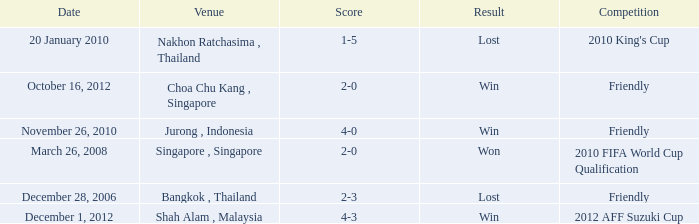Name the date for score of 1-5 20 January 2010. 